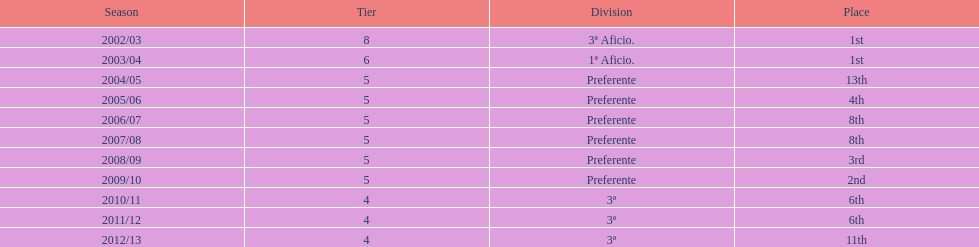What was the total count of preferente's wins? 6. 